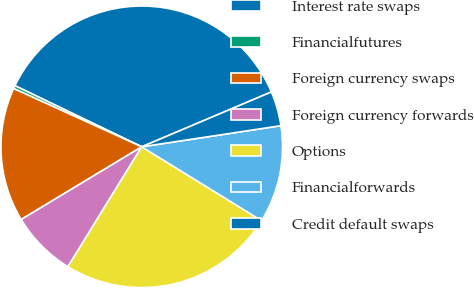<chart> <loc_0><loc_0><loc_500><loc_500><pie_chart><fcel>Interest rate swaps<fcel>Financialfutures<fcel>Foreign currency swaps<fcel>Foreign currency forwards<fcel>Options<fcel>Financialforwards<fcel>Credit default swaps<nl><fcel>36.48%<fcel>0.36%<fcel>15.43%<fcel>7.58%<fcel>24.99%<fcel>11.19%<fcel>3.97%<nl></chart> 